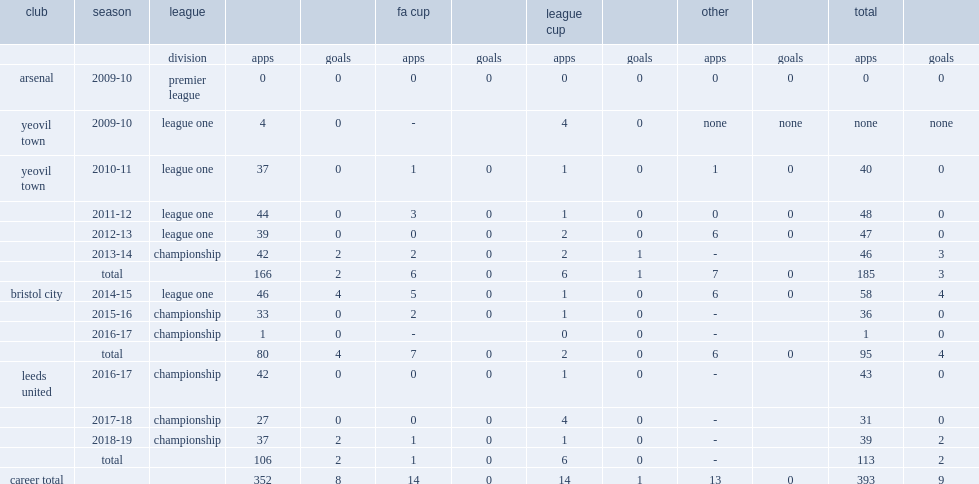Which league did luke ayling appear with yeovil town during the 2013-14 season? Championship. 